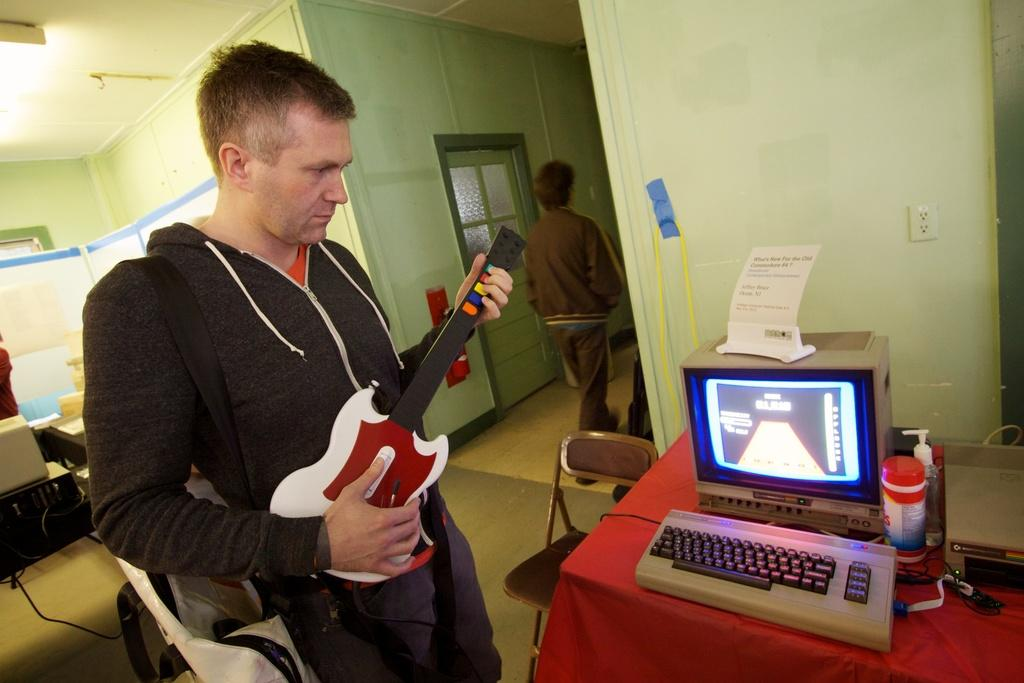Who is present in the image? There is a person in the image. What is the person holding? The person is holding a toy guitar. What can be seen on the table in front of the person? There is a system on a table in front of the person. Can you describe the activity happening in the background of the image? There is a person walking in the background of the image. What type of coal is being used to fuel the system in the image? There is no coal present in the image, and the system's power source is not mentioned. How many pieces of lumber are visible in the image? There is no lumber present in the image. 